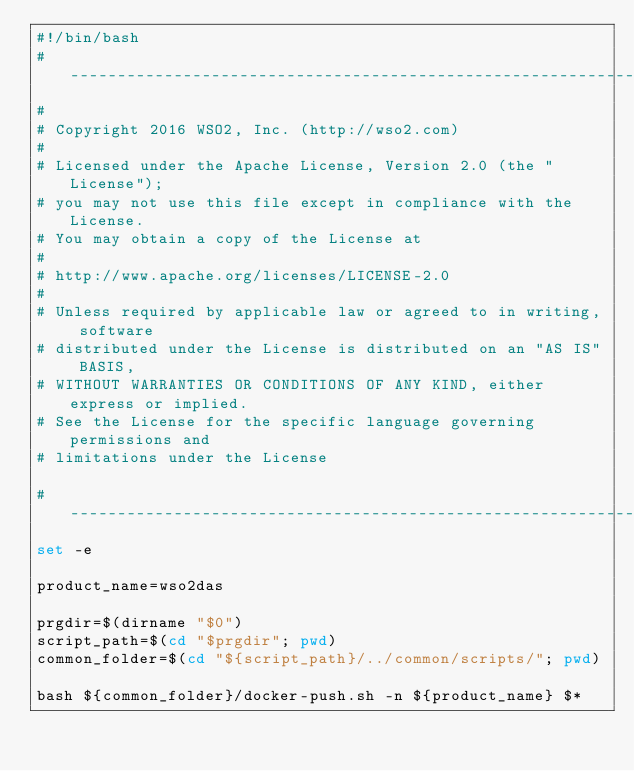Convert code to text. <code><loc_0><loc_0><loc_500><loc_500><_Bash_>#!/bin/bash
# ------------------------------------------------------------------------
#
# Copyright 2016 WSO2, Inc. (http://wso2.com)
#
# Licensed under the Apache License, Version 2.0 (the "License");
# you may not use this file except in compliance with the License.
# You may obtain a copy of the License at
#
# http://www.apache.org/licenses/LICENSE-2.0
#
# Unless required by applicable law or agreed to in writing, software
# distributed under the License is distributed on an "AS IS" BASIS,
# WITHOUT WARRANTIES OR CONDITIONS OF ANY KIND, either express or implied.
# See the License for the specific language governing permissions and
# limitations under the License

# ------------------------------------------------------------------------
set -e

product_name=wso2das

prgdir=$(dirname "$0")
script_path=$(cd "$prgdir"; pwd)
common_folder=$(cd "${script_path}/../common/scripts/"; pwd)

bash ${common_folder}/docker-push.sh -n ${product_name} $*
</code> 